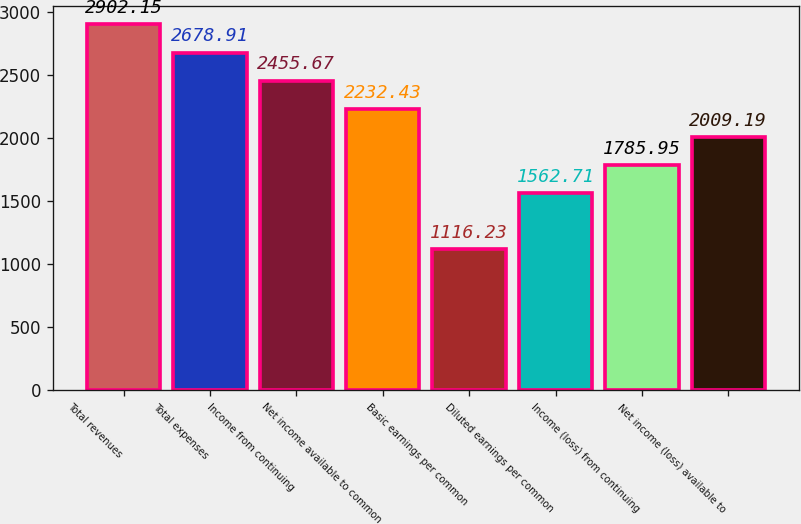<chart> <loc_0><loc_0><loc_500><loc_500><bar_chart><fcel>Total revenues<fcel>Total expenses<fcel>Income from continuing<fcel>Net income available to common<fcel>Basic earnings per common<fcel>Diluted earnings per common<fcel>Income (loss) from continuing<fcel>Net income (loss) available to<nl><fcel>2902.15<fcel>2678.91<fcel>2455.67<fcel>2232.43<fcel>1116.23<fcel>1562.71<fcel>1785.95<fcel>2009.19<nl></chart> 